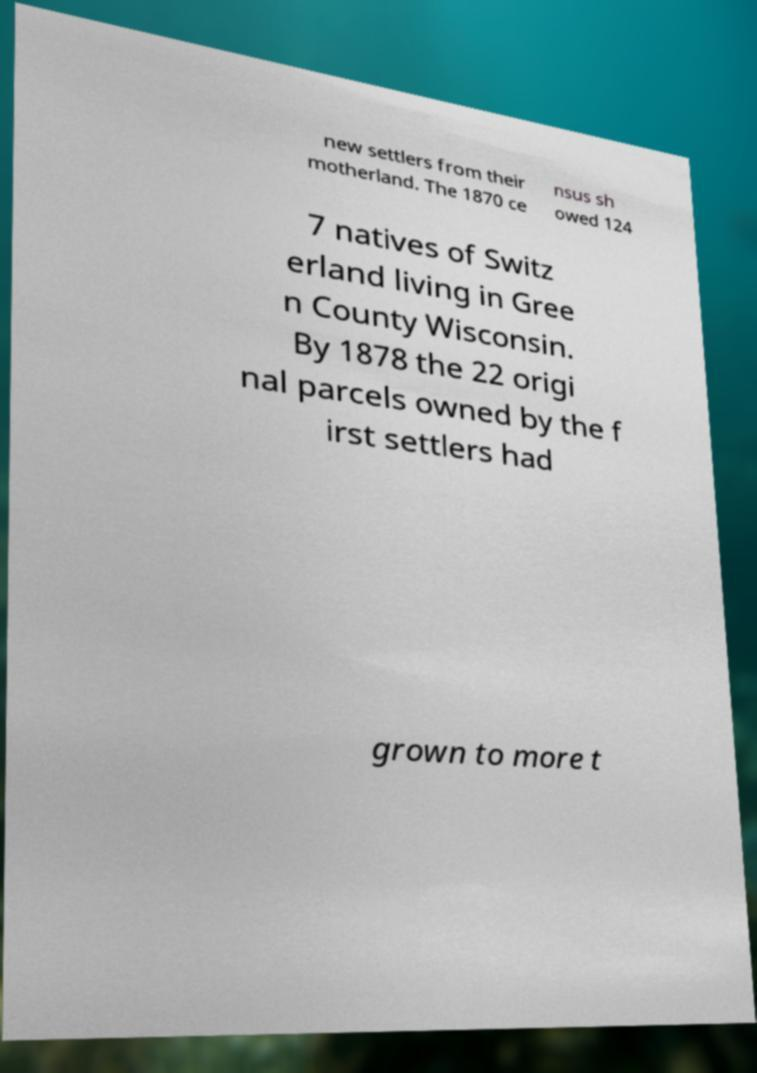Please read and relay the text visible in this image. What does it say? new settlers from their motherland. The 1870 ce nsus sh owed 124 7 natives of Switz erland living in Gree n County Wisconsin. By 1878 the 22 origi nal parcels owned by the f irst settlers had grown to more t 